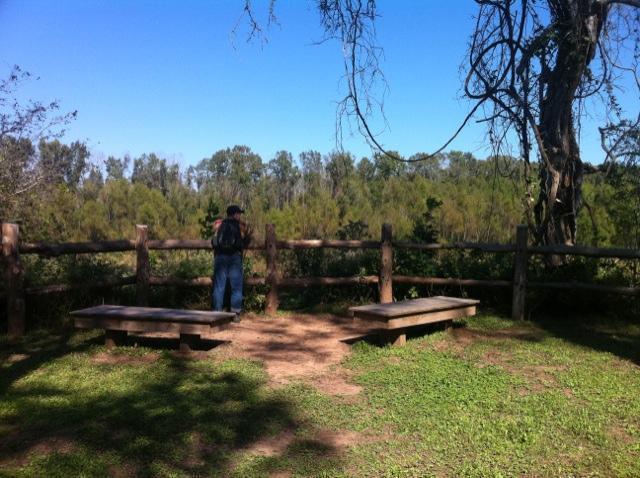What is the person leaning against?
Indicate the correct response by choosing from the four available options to answer the question.
Options: Fence, cross, horse, egg. Fence. 